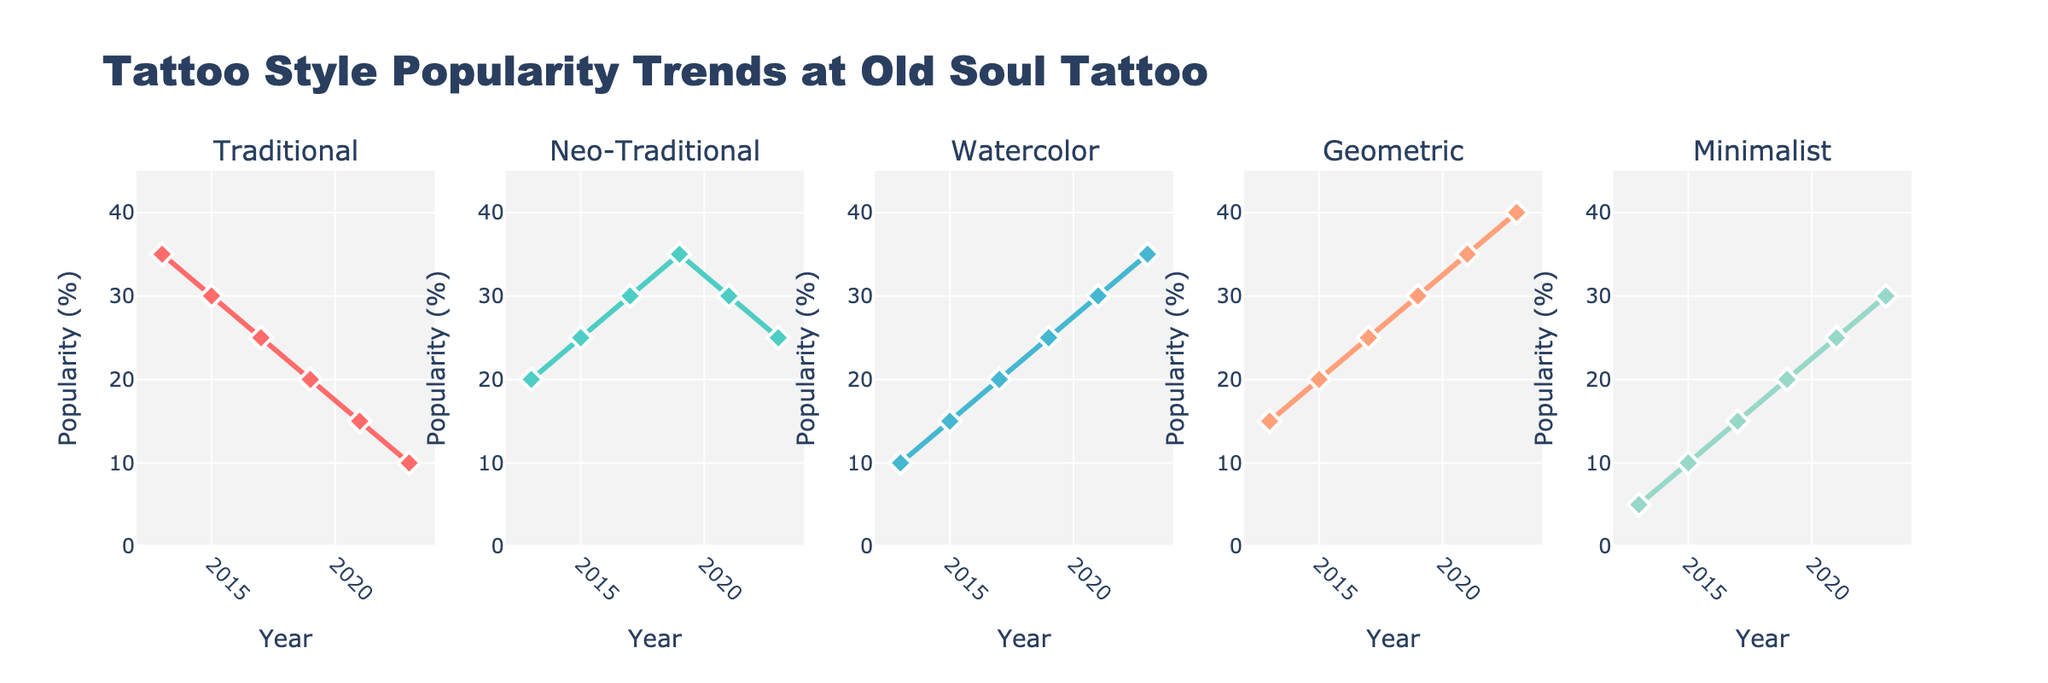What's the title of the plot? The title of the plot is displayed at the top center of the figure in large font. It says "Funding Sources Breakdown (2013-2022)".
Answer: Funding Sources Breakdown (2013-2022) How many funding sources are represented in the figure? The figure shows subplots for five different funding sources, each with its own subplot and title.
Answer: Five Which funding source had the highest increase in amount from 2013 to 2022? By observing the trend lines in the subplots, the "Government Grants" plot shows the largest increase, as the amount goes from $450,000 in 2013 to $675,000 in 2022.
Answer: Government Grants Which funding source consistently increased every year from 2013 to 2022? By looking at the trend lines, it can be observed that "Government Grants" had a steady increase each year without any decreases.
Answer: Government Grants What is the approximate total amount received from Private Donations in 2018 and 2019? To find the total amount, add the values from the "Private Donations" subplot for 2018 and 2019: $195,000 + $210,000 = $405,000.
Answer: $405,000 Compare the contributions from Government Grants and Corporate Sponsorships in 2020. Which one was higher and by how much? By checking the subplots for 2020, Government Grants had $625,000 and Corporate Sponsorships had $55,000. The difference is $625,000 - $55,000 = $570,000.
Answer: Government Grants by $570,000 What is the percentage increase in Insurance Reimbursements from 2013 to 2022? Calculate the percentage increase using the formula [(Final - Initial) / Initial] * 100. For Insurance Reimbursements: [(315,000 - 180,000) / 180,000] * 100 = 75%.
Answer: 75% Which funding source had the least fluctuation in amounts over the years? By observing the plots, "Corporate Sponsorships" seems to have the least fluctuation as the amount steadily increases by $5,000 each year.
Answer: Corporate Sponsorships What are the values for Fundraising Events in 2014 and 2017? Refer to the subplot for Fundraising Events; the amounts are $55,000 in 2014 and $70,000 in 2017.
Answer: $55,000 and $70,000 